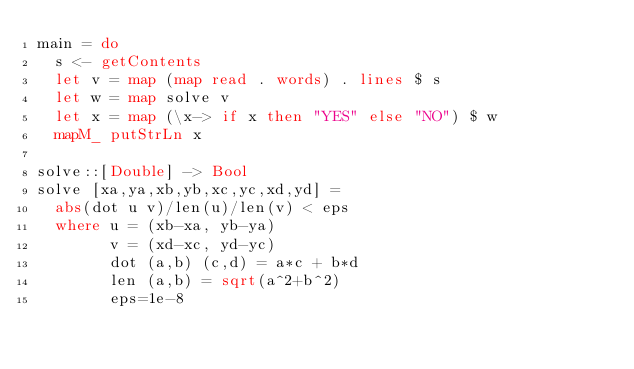Convert code to text. <code><loc_0><loc_0><loc_500><loc_500><_Haskell_>main = do
  s <- getContents
  let v = map (map read . words) . lines $ s
  let w = map solve v
  let x = map (\x-> if x then "YES" else "NO") $ w
  mapM_ putStrLn x

solve::[Double] -> Bool
solve [xa,ya,xb,yb,xc,yc,xd,yd] =
  abs(dot u v)/len(u)/len(v) < eps
  where u = (xb-xa, yb-ya)
        v = (xd-xc, yd-yc)
        dot (a,b) (c,d) = a*c + b*d
        len (a,b) = sqrt(a^2+b^2)
        eps=1e-8</code> 